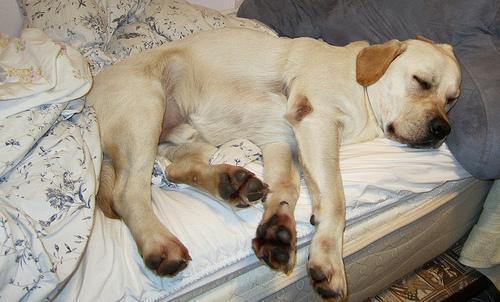How many dogs are in the picture?
Give a very brief answer. 1. 